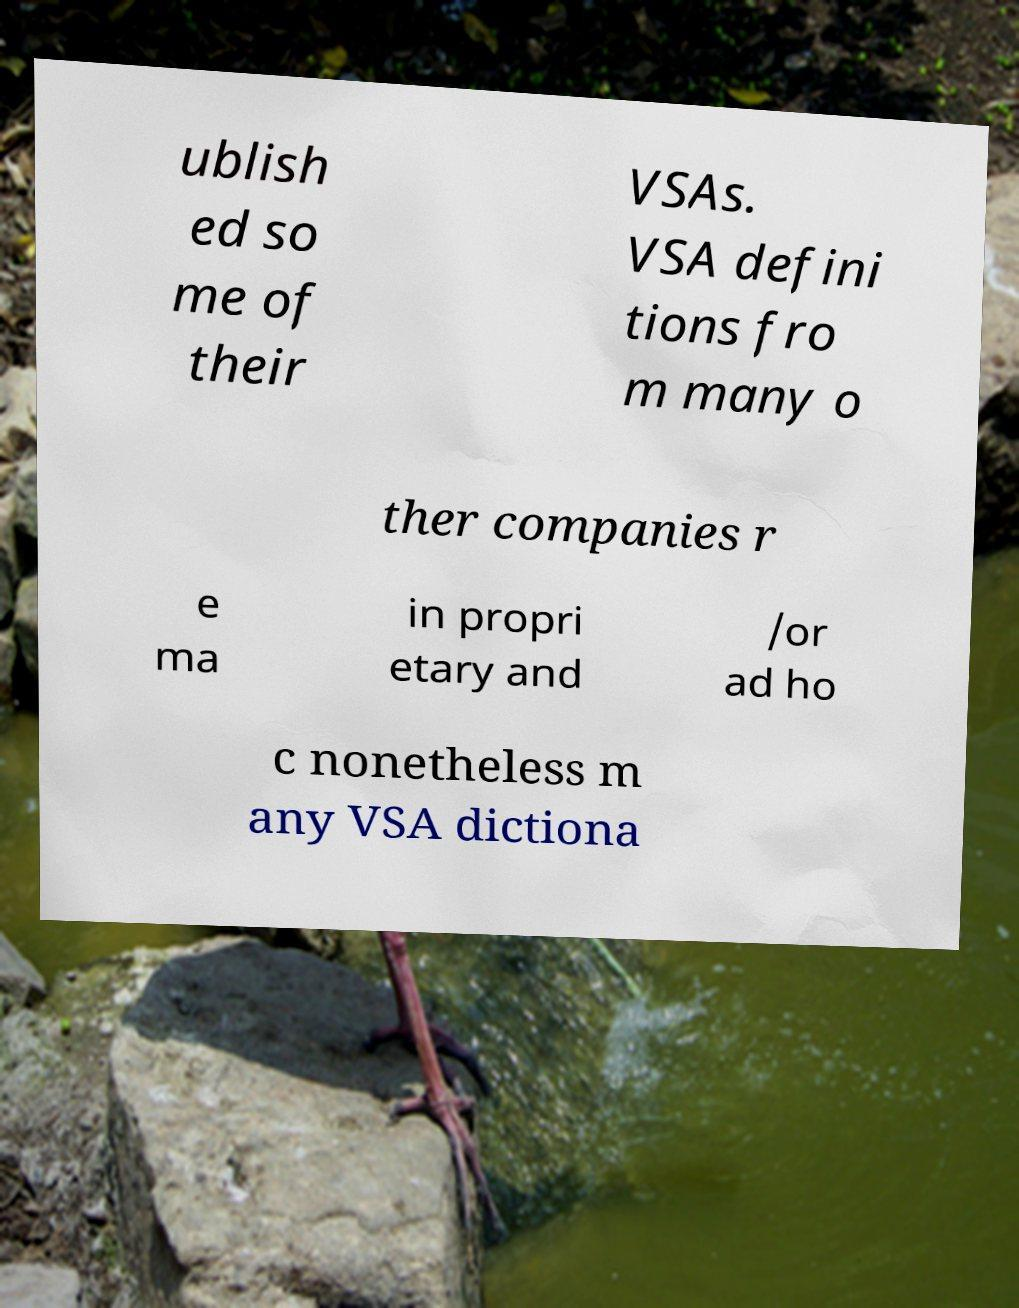Please read and relay the text visible in this image. What does it say? ublish ed so me of their VSAs. VSA defini tions fro m many o ther companies r e ma in propri etary and /or ad ho c nonetheless m any VSA dictiona 